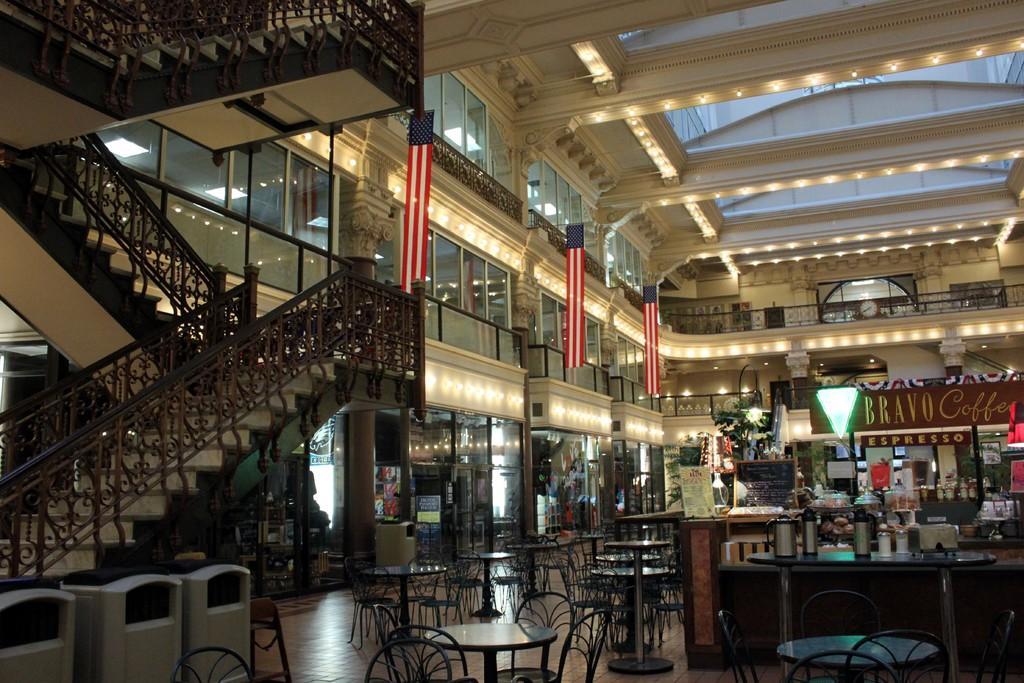How would you summarize this image in a sentence or two? In the picture I can see chairs, tables which has some objects, flags attached to the walls, a board which has something written on it and some other objects. I can also see lights on the ceiling, fence and glass walls. This is an inside view of a building. 